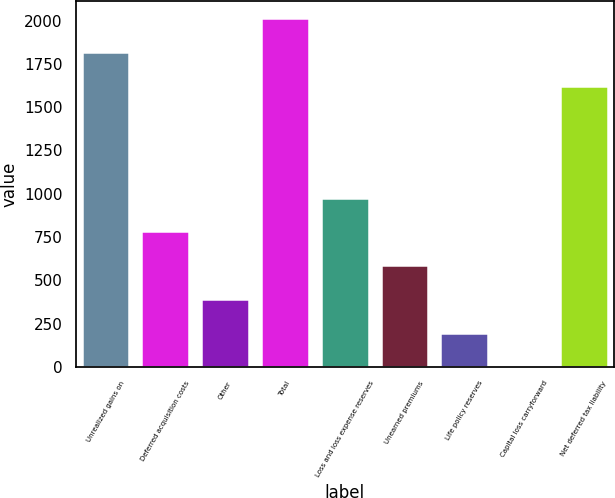Convert chart to OTSL. <chart><loc_0><loc_0><loc_500><loc_500><bar_chart><fcel>Unrealized gains on<fcel>Deferred acquisition costs<fcel>Other<fcel>Total<fcel>Loss and loss expense reserves<fcel>Unearned premiums<fcel>Life policy reserves<fcel>Capital loss carryforward<fcel>Net deferred tax liability<nl><fcel>1817.33<fcel>783.05<fcel>392.39<fcel>2012.66<fcel>978.38<fcel>587.72<fcel>197.06<fcel>1.73<fcel>1622<nl></chart> 